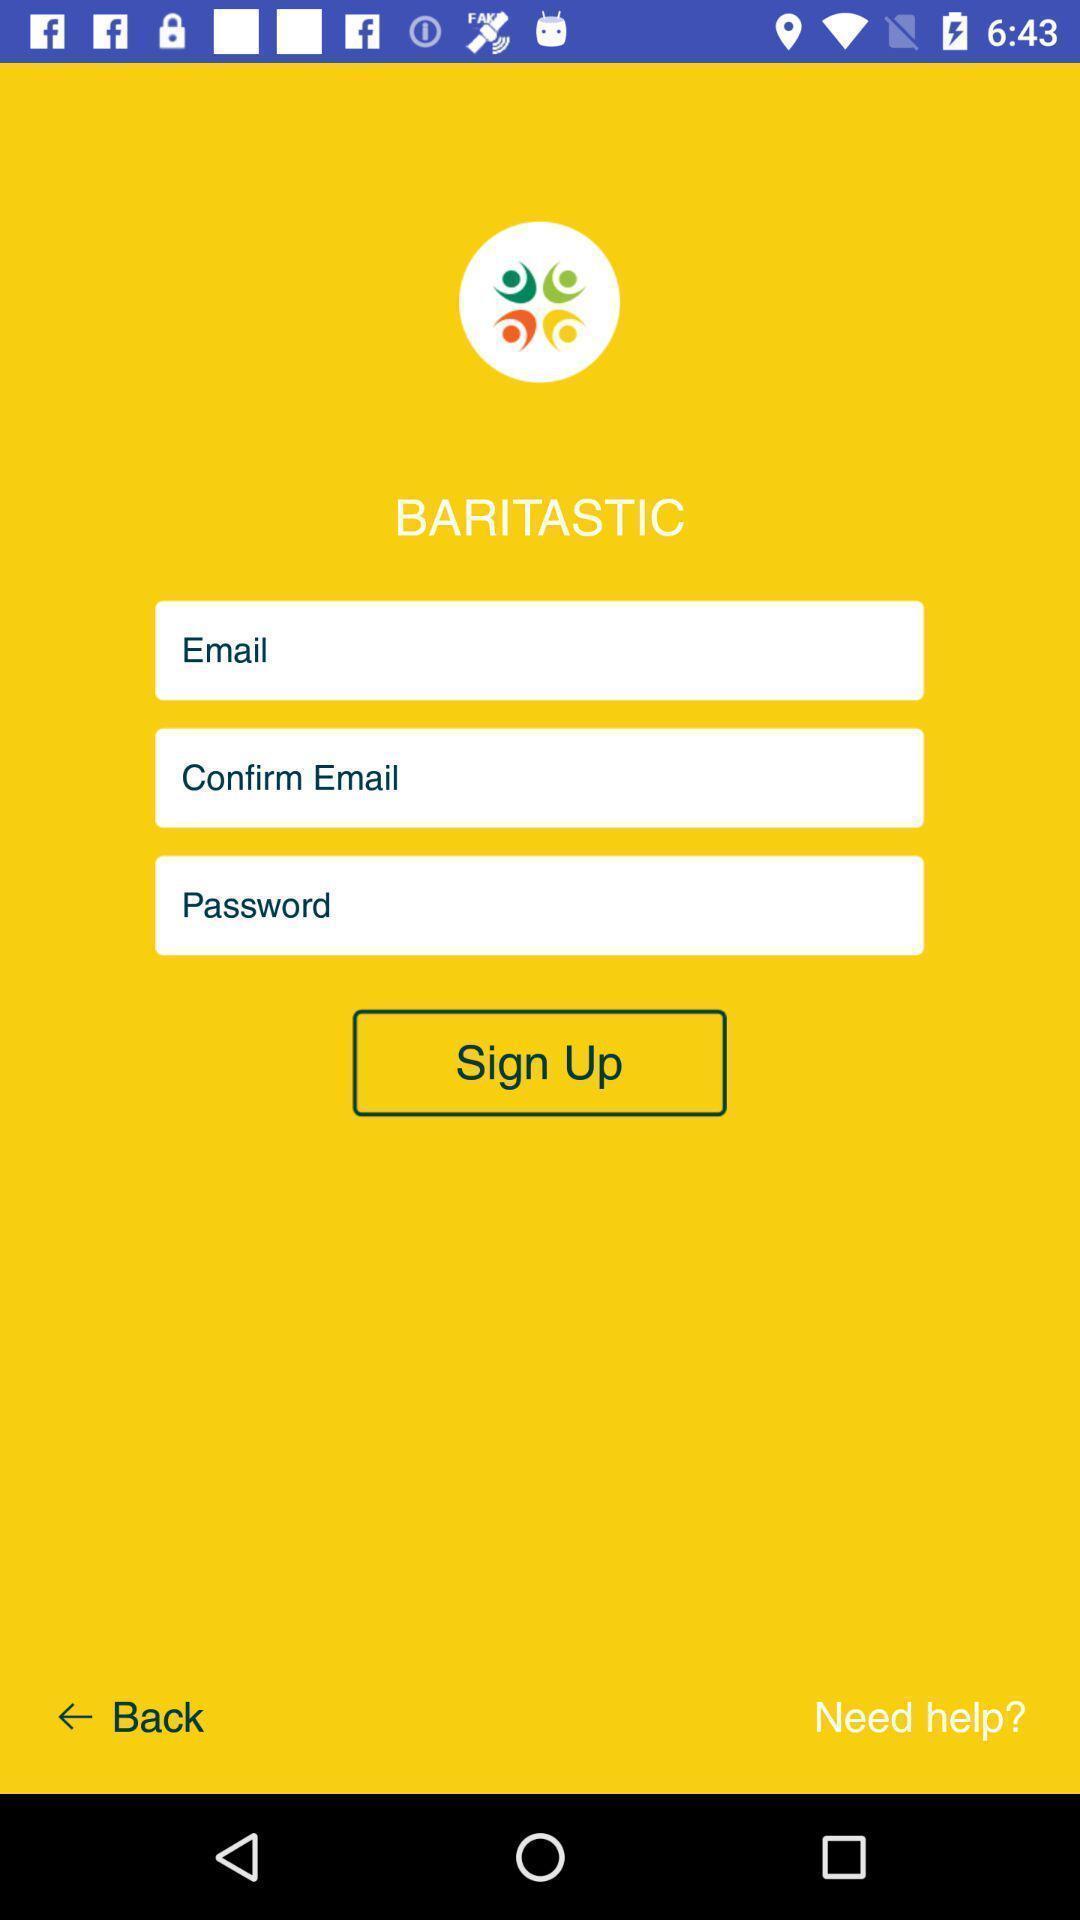Give me a narrative description of this picture. Welcome page displaying to enter details. 